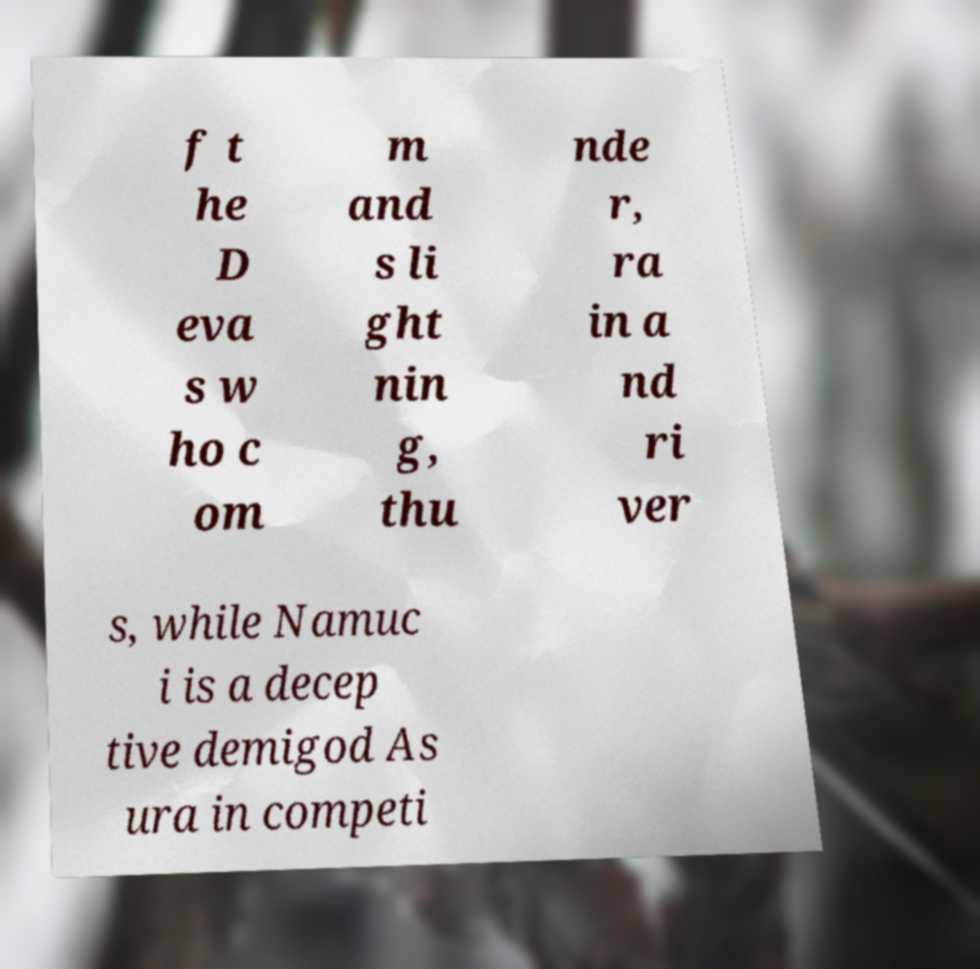For documentation purposes, I need the text within this image transcribed. Could you provide that? f t he D eva s w ho c om m and s li ght nin g, thu nde r, ra in a nd ri ver s, while Namuc i is a decep tive demigod As ura in competi 